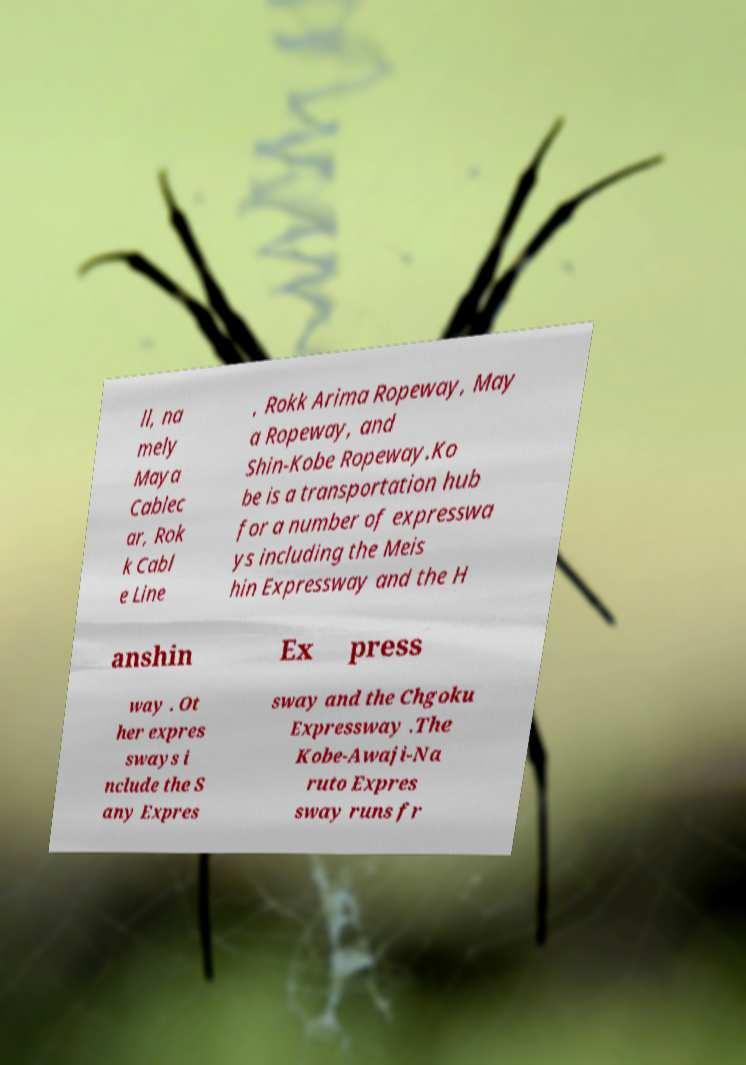What messages or text are displayed in this image? I need them in a readable, typed format. ll, na mely Maya Cablec ar, Rok k Cabl e Line , Rokk Arima Ropeway, May a Ropeway, and Shin-Kobe Ropeway.Ko be is a transportation hub for a number of expresswa ys including the Meis hin Expressway and the H anshin Ex press way . Ot her expres sways i nclude the S any Expres sway and the Chgoku Expressway .The Kobe-Awaji-Na ruto Expres sway runs fr 